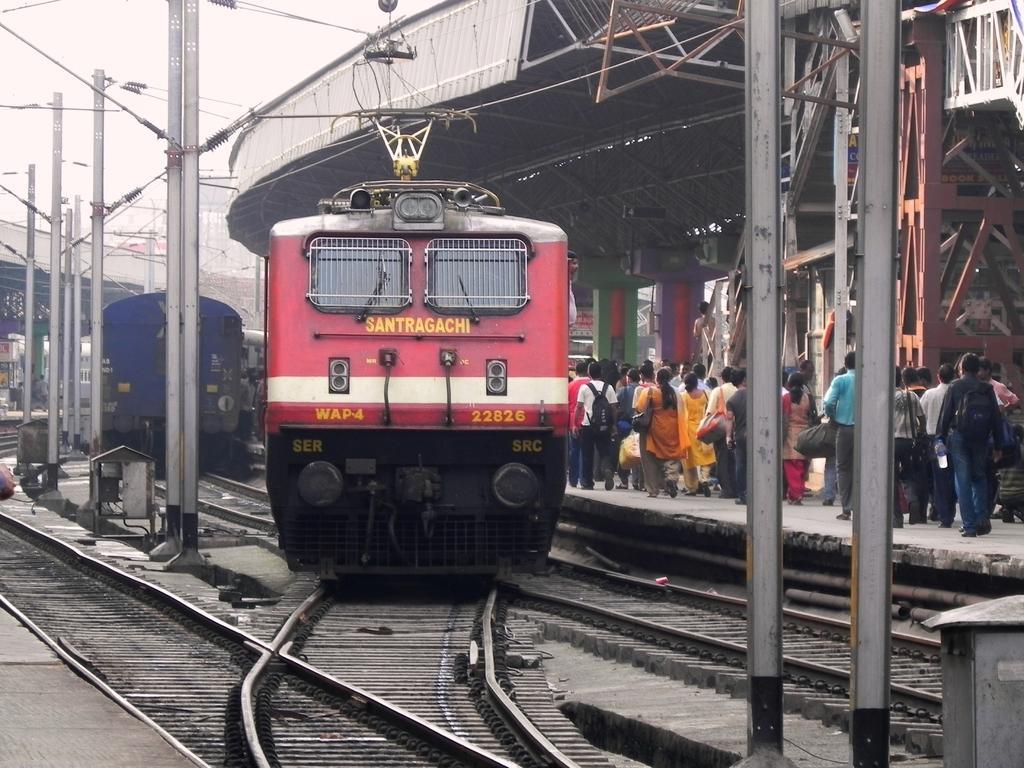How would you summarize this image in a sentence or two? In the center of the image we can see trains. On the right side of the image we can see shed, poles, wires, some persons are walking on platform and carrying bags. At the bottom of the image we can railway track, platform. At the top of the image there is a sky. 